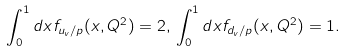<formula> <loc_0><loc_0><loc_500><loc_500>\int _ { 0 } ^ { 1 } d x f _ { u _ { v } / p } ( x , Q ^ { 2 } ) = 2 , \, \int _ { 0 } ^ { 1 } d x f _ { d _ { v } / p } ( x , Q ^ { 2 } ) = 1 .</formula> 